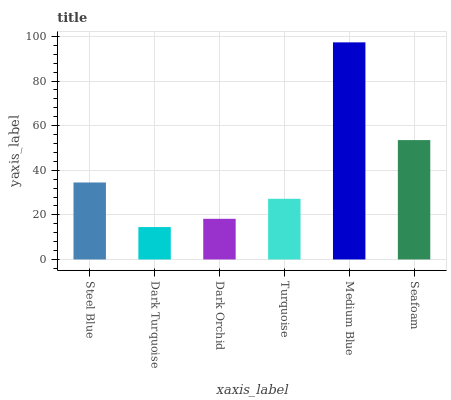Is Dark Turquoise the minimum?
Answer yes or no. Yes. Is Medium Blue the maximum?
Answer yes or no. Yes. Is Dark Orchid the minimum?
Answer yes or no. No. Is Dark Orchid the maximum?
Answer yes or no. No. Is Dark Orchid greater than Dark Turquoise?
Answer yes or no. Yes. Is Dark Turquoise less than Dark Orchid?
Answer yes or no. Yes. Is Dark Turquoise greater than Dark Orchid?
Answer yes or no. No. Is Dark Orchid less than Dark Turquoise?
Answer yes or no. No. Is Steel Blue the high median?
Answer yes or no. Yes. Is Turquoise the low median?
Answer yes or no. Yes. Is Dark Turquoise the high median?
Answer yes or no. No. Is Dark Turquoise the low median?
Answer yes or no. No. 